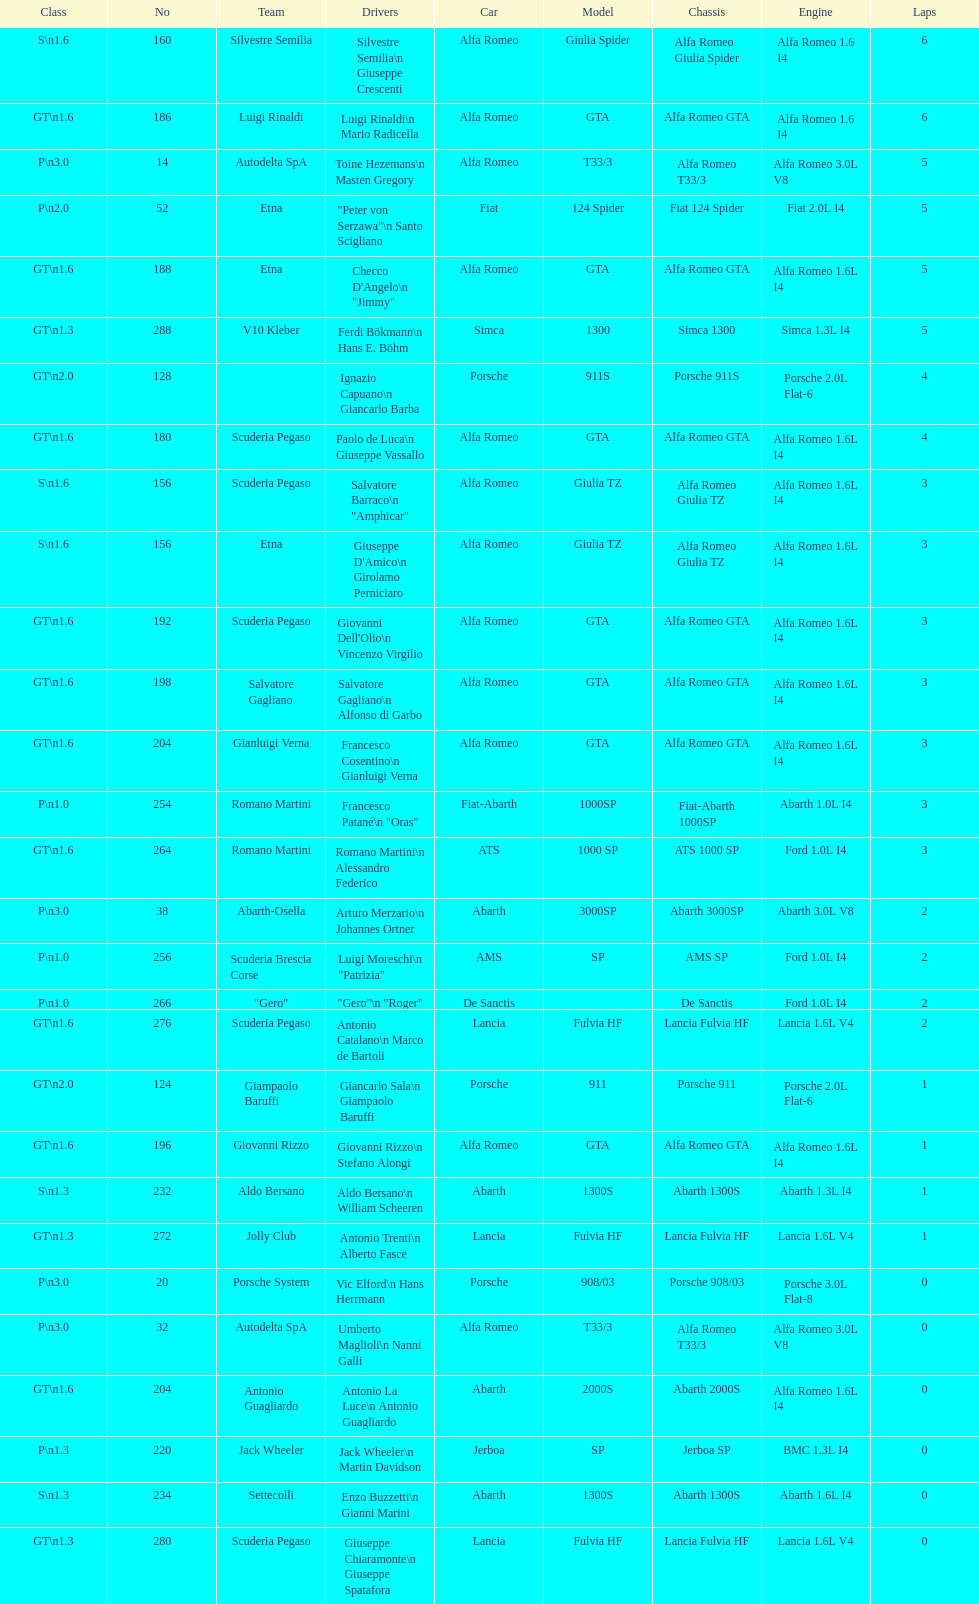How many teams were unable to complete the race after 2 laps? 4. Can you parse all the data within this table? {'header': ['Class', 'No', 'Team', 'Drivers', 'Car', 'Model', 'Chassis', 'Engine', 'Laps'], 'rows': [['S\\n1.6', '160', 'Silvestre Semilia', 'Silvestre Semilia\\n Giuseppe Crescenti', 'Alfa Romeo', 'Giulia Spider', 'Alfa Romeo Giulia Spider', 'Alfa Romeo 1.6 I4', '6'], ['GT\\n1.6', '186', 'Luigi Rinaldi', 'Luigi Rinaldi\\n Mario Radicella', 'Alfa Romeo', 'GTA', 'Alfa Romeo GTA', 'Alfa Romeo 1.6 I4', '6'], ['P\\n3.0', '14', 'Autodelta SpA', 'Toine Hezemans\\n Masten Gregory', 'Alfa Romeo', 'T33/3', 'Alfa Romeo T33/3', 'Alfa Romeo 3.0L V8', '5'], ['P\\n2.0', '52', 'Etna', '"Peter von Serzawa"\\n Santo Scigliano', 'Fiat', '124 Spider', 'Fiat 124 Spider', 'Fiat 2.0L I4', '5'], ['GT\\n1.6', '188', 'Etna', 'Checco D\'Angelo\\n "Jimmy"', 'Alfa Romeo', 'GTA', 'Alfa Romeo GTA', 'Alfa Romeo 1.6L I4', '5'], ['GT\\n1.3', '288', 'V10 Kleber', 'Ferdi Bökmann\\n Hans E. Böhm', 'Simca', '1300', 'Simca 1300', 'Simca 1.3L I4', '5'], ['GT\\n2.0', '128', '', 'Ignazio Capuano\\n Giancarlo Barba', 'Porsche', '911S', 'Porsche 911S', 'Porsche 2.0L Flat-6', '4'], ['GT\\n1.6', '180', 'Scuderia Pegaso', 'Paolo de Luca\\n Giuseppe Vassallo', 'Alfa Romeo', 'GTA', 'Alfa Romeo GTA', 'Alfa Romeo 1.6L I4', '4'], ['S\\n1.6', '156', 'Scuderia Pegaso', 'Salvatore Barraco\\n "Amphicar"', 'Alfa Romeo', 'Giulia TZ', 'Alfa Romeo Giulia TZ', 'Alfa Romeo 1.6L I4', '3'], ['S\\n1.6', '156', 'Etna', "Giuseppe D'Amico\\n Girolamo Perniciaro", 'Alfa Romeo', 'Giulia TZ', 'Alfa Romeo Giulia TZ', 'Alfa Romeo 1.6L I4', '3'], ['GT\\n1.6', '192', 'Scuderia Pegaso', "Giovanni Dell'Olio\\n Vincenzo Virgilio", 'Alfa Romeo', 'GTA', 'Alfa Romeo GTA', 'Alfa Romeo 1.6L I4', '3'], ['GT\\n1.6', '198', 'Salvatore Gagliano', 'Salvatore Gagliano\\n Alfonso di Garbo', 'Alfa Romeo', 'GTA', 'Alfa Romeo GTA', 'Alfa Romeo 1.6L I4', '3'], ['GT\\n1.6', '204', 'Gianluigi Verna', 'Francesco Cosentino\\n Gianluigi Verna', 'Alfa Romeo', 'GTA', 'Alfa Romeo GTA', 'Alfa Romeo 1.6L I4', '3'], ['P\\n1.0', '254', 'Romano Martini', 'Francesco Patané\\n "Oras"', 'Fiat-Abarth', '1000SP', 'Fiat-Abarth 1000SP', 'Abarth 1.0L I4', '3'], ['GT\\n1.6', '264', 'Romano Martini', 'Romano Martini\\n Alessandro Federico', 'ATS', '1000 SP', 'ATS 1000 SP', 'Ford 1.0L I4', '3'], ['P\\n3.0', '38', 'Abarth-Osella', 'Arturo Merzario\\n Johannes Ortner', 'Abarth', '3000SP', 'Abarth 3000SP', 'Abarth 3.0L V8', '2'], ['P\\n1.0', '256', 'Scuderia Brescia Corse', 'Luigi Moreschi\\n "Patrizia"', 'AMS', 'SP', 'AMS SP', 'Ford 1.0L I4', '2'], ['P\\n1.0', '266', '"Gero"', '"Gero"\\n "Roger"', 'De Sanctis', '', 'De Sanctis', 'Ford 1.0L I4', '2'], ['GT\\n1.6', '276', 'Scuderia Pegaso', 'Antonio Catalano\\n Marco de Bartoli', 'Lancia', 'Fulvia HF', 'Lancia Fulvia HF', 'Lancia 1.6L V4', '2'], ['GT\\n2.0', '124', 'Giampaolo Baruffi', 'Giancarlo Sala\\n Giampaolo Baruffi', 'Porsche', '911', 'Porsche 911', 'Porsche 2.0L Flat-6', '1'], ['GT\\n1.6', '196', 'Giovanni Rizzo', 'Giovanni Rizzo\\n Stefano Alongi', 'Alfa Romeo', 'GTA', 'Alfa Romeo GTA', 'Alfa Romeo 1.6L I4', '1'], ['S\\n1.3', '232', 'Aldo Bersano', 'Aldo Bersano\\n William Scheeren', 'Abarth', '1300S', 'Abarth 1300S', 'Abarth 1.3L I4', '1'], ['GT\\n1.3', '272', 'Jolly Club', 'Antonio Trenti\\n Alberto Fasce', 'Lancia', 'Fulvia HF', 'Lancia Fulvia HF', 'Lancia 1.6L V4', '1'], ['P\\n3.0', '20', 'Porsche System', 'Vic Elford\\n Hans Herrmann', 'Porsche', '908/03', 'Porsche 908/03', 'Porsche 3.0L Flat-8', '0'], ['P\\n3.0', '32', 'Autodelta SpA', 'Umberto Maglioli\\n Nanni Galli', 'Alfa Romeo', 'T33/3', 'Alfa Romeo T33/3', 'Alfa Romeo 3.0L V8', '0'], ['GT\\n1.6', '204', 'Antonio Guagliardo', 'Antonio La Luce\\n Antonio Guagliardo', 'Abarth', '2000S', 'Abarth 2000S', 'Alfa Romeo 1.6L I4', '0'], ['P\\n1.3', '220', 'Jack Wheeler', 'Jack Wheeler\\n Martin Davidson', 'Jerboa', 'SP', 'Jerboa SP', 'BMC 1.3L I4', '0'], ['S\\n1.3', '234', 'Settecolli', 'Enzo Buzzetti\\n Gianni Marini', 'Abarth', '1300S', 'Abarth 1300S', 'Abarth 1.6L I4', '0'], ['GT\\n1.3', '280', 'Scuderia Pegaso', 'Giuseppe Chiaramonte\\n Giuseppe Spatafora', 'Lancia', 'Fulvia HF', 'Lancia Fulvia HF', 'Lancia 1.6L V4', '0']]} 